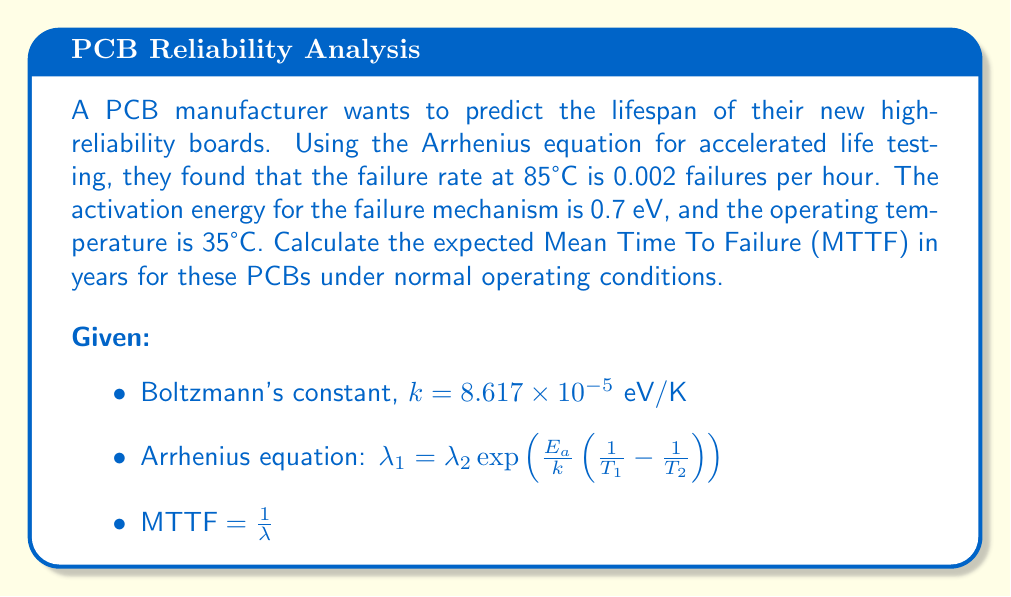Give your solution to this math problem. To solve this problem, we'll follow these steps:

1) Convert temperatures to Kelvin:
   $T_1 = 35°C + 273.15 = 308.15$ K (operating temperature)
   $T_2 = 85°C + 273.15 = 358.15$ K (test temperature)

2) Use the Arrhenius equation to find the failure rate at operating temperature:

   $$\lambda_1 = \lambda_2 \exp\left(\frac{E_a}{k}\left(\frac{1}{T_1} - \frac{1}{T_2}\right)\right)$$

   $$\lambda_1 = 0.002 \exp\left(\frac{0.7}{8.617 \times 10^{-5}}\left(\frac{1}{308.15} - \frac{1}{358.15}\right)\right)$$

3) Calculate the exponent:
   $$\frac{0.7}{8.617 \times 10^{-5}}\left(\frac{1}{308.15} - \frac{1}{358.15}\right) = 8126.38 \times (0.003245 - 0.002792) = 3.68$$

4) Solve for $\lambda_1$:
   $$\lambda_1 = 0.002 \times e^{-3.68} = 0.002 \times 0.02524 = 5.048 \times 10^{-5} \text{ failures/hour}$$

5) Calculate MTTF:
   $$\text{MTTF} = \frac{1}{\lambda_1} = \frac{1}{5.048 \times 10^{-5}} = 19,810 \text{ hours}$$

6) Convert MTTF to years:
   $$\text{MTTF in years} = \frac{19,810 \text{ hours}}{24 \text{ hours/day} \times 365.25 \text{ days/year}} = 2.26 \text{ years}$$
Answer: 2.26 years 